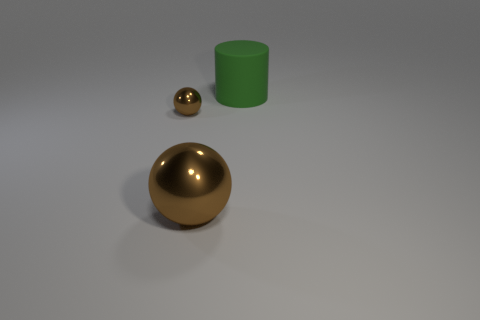Are there more matte objects that are in front of the large brown shiny object than big metal spheres that are behind the big green object?
Provide a short and direct response. No. The thing that is left of the large green matte object and behind the big metal object has what shape?
Provide a succinct answer. Sphere. What is the shape of the large thing in front of the tiny sphere?
Your response must be concise. Sphere. How big is the brown shiny object that is on the right side of the brown sphere left of the big object that is in front of the big green cylinder?
Ensure brevity in your answer.  Large. Is the shape of the small brown metallic thing the same as the big green matte object?
Offer a terse response. No. What size is the thing that is both behind the big brown shiny ball and left of the rubber cylinder?
Offer a terse response. Small. There is a small thing that is the same shape as the big brown metal object; what is its material?
Keep it short and to the point. Metal. There is a brown sphere that is to the left of the big thing that is to the left of the cylinder; what is its material?
Give a very brief answer. Metal. Is the shape of the green object the same as the large object that is in front of the small brown metal ball?
Offer a terse response. No. What number of rubber objects are green cylinders or big things?
Provide a short and direct response. 1. 